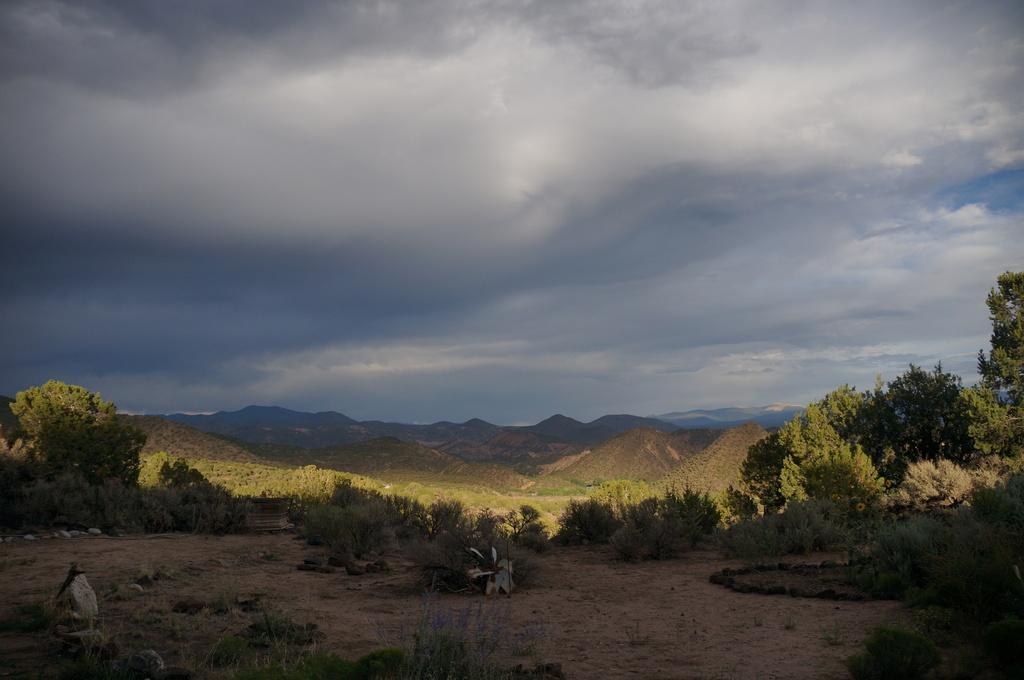In one or two sentences, can you explain what this image depicts? In this image there are plants and trees on the land. Background there are hills. Top of the image there is sky. Bottom of the image there are rocks, grass on the land. 